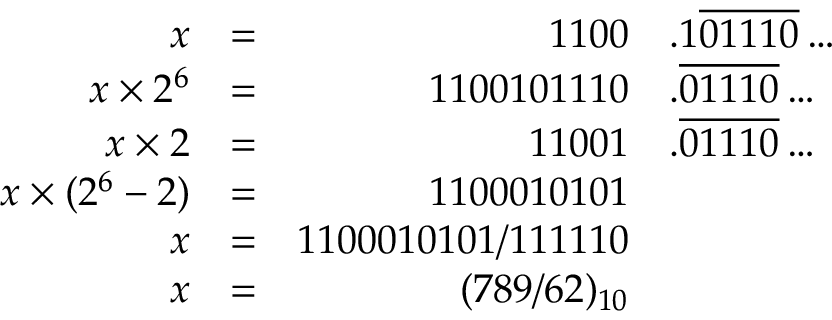Convert formula to latex. <formula><loc_0><loc_0><loc_500><loc_500>{ \begin{array} { r l r l } { x } & { = } & { 1 1 0 0 } & { . 1 { \overline { 0 1 1 1 0 } } \dots } \\ { x \times 2 ^ { 6 } } & { = } & { 1 1 0 0 1 0 1 1 1 0 } & { . { \overline { 0 1 1 1 0 } } \dots } \\ { x \times 2 } & { = } & { 1 1 0 0 1 } & { . { \overline { 0 1 1 1 0 } } \dots } \\ { x \times ( 2 ^ { 6 } - 2 ) } & { = } & { 1 1 0 0 0 1 0 1 0 1 } \\ { x } & { = } & { 1 1 0 0 0 1 0 1 0 1 / 1 1 1 1 1 0 } \\ { x } & { = } & { ( 7 8 9 / 6 2 ) _ { 1 0 } } \end{array} }</formula> 